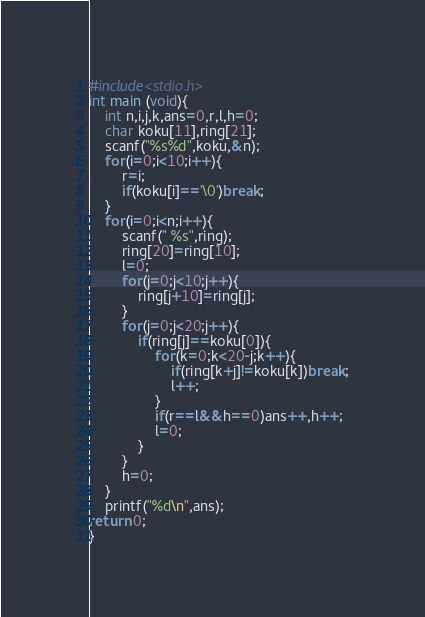<code> <loc_0><loc_0><loc_500><loc_500><_C_>#include<stdio.h>
int main (void){
    int n,i,j,k,ans=0,r,l,h=0;
    char koku[11],ring[21];
    scanf("%s%d",koku,&n);
    for(i=0;i<10;i++){
        r=i;
        if(koku[i]=='\0')break;
    }
    for(i=0;i<n;i++){
        scanf(" %s",ring);
        ring[20]=ring[10];
        l=0;
        for(j=0;j<10;j++){
            ring[j+10]=ring[j];
        }
        for(j=0;j<20;j++){
            if(ring[j]==koku[0]){
                for(k=0;k<20-j;k++){
                    if(ring[k+j]!=koku[k])break;
                    l++;
                }
                if(r==l&&h==0)ans++,h++;
                l=0;
            }
        }
        h=0;
    }
    printf("%d\n",ans);
return 0;
}</code> 